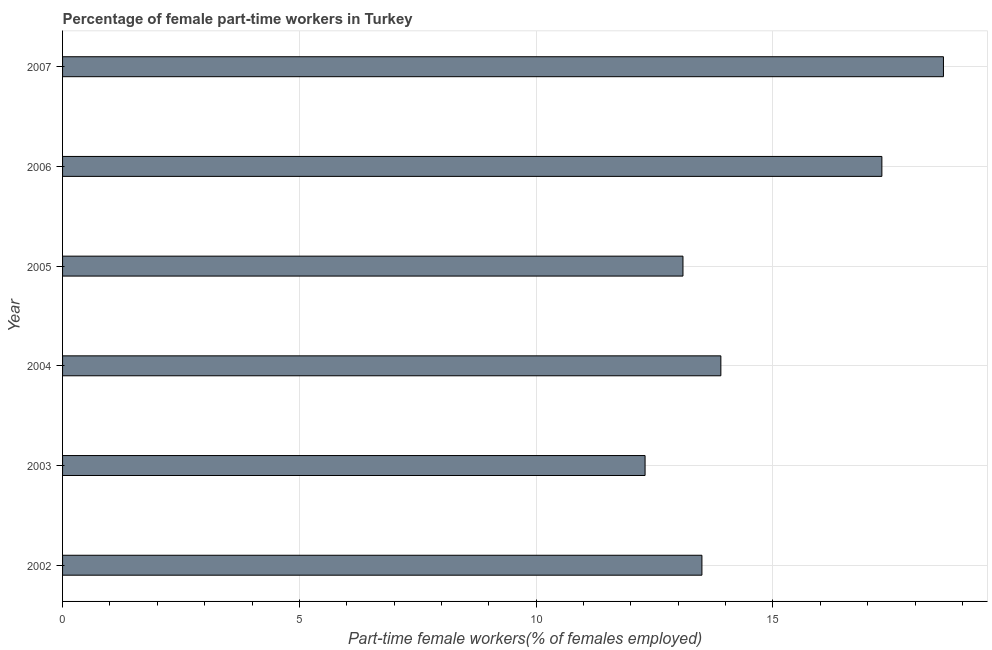What is the title of the graph?
Provide a short and direct response. Percentage of female part-time workers in Turkey. What is the label or title of the X-axis?
Your answer should be compact. Part-time female workers(% of females employed). What is the percentage of part-time female workers in 2004?
Your answer should be compact. 13.9. Across all years, what is the maximum percentage of part-time female workers?
Your answer should be very brief. 18.6. Across all years, what is the minimum percentage of part-time female workers?
Provide a short and direct response. 12.3. In which year was the percentage of part-time female workers maximum?
Make the answer very short. 2007. In which year was the percentage of part-time female workers minimum?
Provide a succinct answer. 2003. What is the sum of the percentage of part-time female workers?
Give a very brief answer. 88.7. What is the average percentage of part-time female workers per year?
Keep it short and to the point. 14.78. What is the median percentage of part-time female workers?
Make the answer very short. 13.7. What is the ratio of the percentage of part-time female workers in 2002 to that in 2006?
Offer a very short reply. 0.78. Is the difference between the percentage of part-time female workers in 2002 and 2006 greater than the difference between any two years?
Offer a terse response. No. Is the sum of the percentage of part-time female workers in 2002 and 2003 greater than the maximum percentage of part-time female workers across all years?
Make the answer very short. Yes. What is the difference between the highest and the lowest percentage of part-time female workers?
Your answer should be compact. 6.3. In how many years, is the percentage of part-time female workers greater than the average percentage of part-time female workers taken over all years?
Make the answer very short. 2. How many bars are there?
Provide a succinct answer. 6. Are all the bars in the graph horizontal?
Provide a short and direct response. Yes. How many years are there in the graph?
Offer a terse response. 6. What is the difference between two consecutive major ticks on the X-axis?
Your response must be concise. 5. Are the values on the major ticks of X-axis written in scientific E-notation?
Your response must be concise. No. What is the Part-time female workers(% of females employed) in 2003?
Offer a very short reply. 12.3. What is the Part-time female workers(% of females employed) of 2004?
Make the answer very short. 13.9. What is the Part-time female workers(% of females employed) in 2005?
Provide a succinct answer. 13.1. What is the Part-time female workers(% of females employed) in 2006?
Offer a terse response. 17.3. What is the Part-time female workers(% of females employed) in 2007?
Ensure brevity in your answer.  18.6. What is the difference between the Part-time female workers(% of females employed) in 2002 and 2003?
Offer a terse response. 1.2. What is the difference between the Part-time female workers(% of females employed) in 2002 and 2005?
Keep it short and to the point. 0.4. What is the difference between the Part-time female workers(% of females employed) in 2002 and 2006?
Ensure brevity in your answer.  -3.8. What is the difference between the Part-time female workers(% of females employed) in 2003 and 2004?
Give a very brief answer. -1.6. What is the difference between the Part-time female workers(% of females employed) in 2003 and 2006?
Provide a short and direct response. -5. What is the difference between the Part-time female workers(% of females employed) in 2004 and 2005?
Make the answer very short. 0.8. What is the difference between the Part-time female workers(% of females employed) in 2004 and 2006?
Your answer should be compact. -3.4. What is the ratio of the Part-time female workers(% of females employed) in 2002 to that in 2003?
Offer a terse response. 1.1. What is the ratio of the Part-time female workers(% of females employed) in 2002 to that in 2005?
Provide a succinct answer. 1.03. What is the ratio of the Part-time female workers(% of females employed) in 2002 to that in 2006?
Make the answer very short. 0.78. What is the ratio of the Part-time female workers(% of females employed) in 2002 to that in 2007?
Your answer should be very brief. 0.73. What is the ratio of the Part-time female workers(% of females employed) in 2003 to that in 2004?
Your answer should be very brief. 0.89. What is the ratio of the Part-time female workers(% of females employed) in 2003 to that in 2005?
Ensure brevity in your answer.  0.94. What is the ratio of the Part-time female workers(% of females employed) in 2003 to that in 2006?
Your response must be concise. 0.71. What is the ratio of the Part-time female workers(% of females employed) in 2003 to that in 2007?
Ensure brevity in your answer.  0.66. What is the ratio of the Part-time female workers(% of females employed) in 2004 to that in 2005?
Give a very brief answer. 1.06. What is the ratio of the Part-time female workers(% of females employed) in 2004 to that in 2006?
Your answer should be compact. 0.8. What is the ratio of the Part-time female workers(% of females employed) in 2004 to that in 2007?
Offer a terse response. 0.75. What is the ratio of the Part-time female workers(% of females employed) in 2005 to that in 2006?
Ensure brevity in your answer.  0.76. What is the ratio of the Part-time female workers(% of females employed) in 2005 to that in 2007?
Offer a terse response. 0.7. 